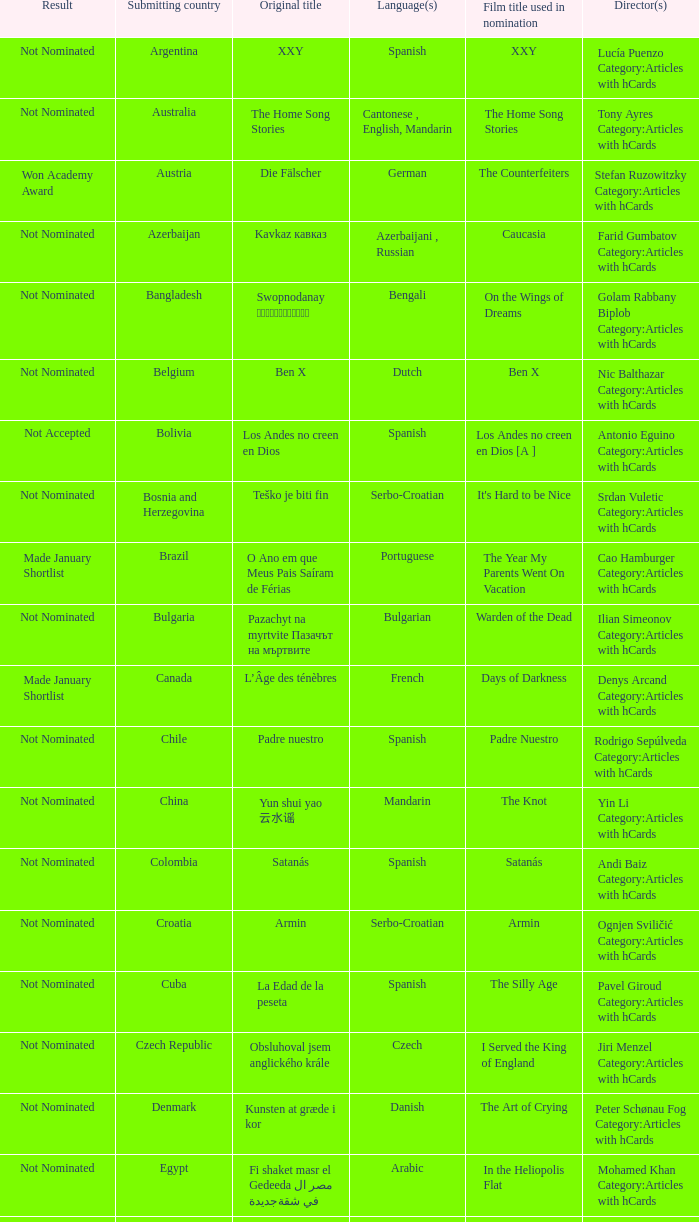What country submitted the movie the orphanage? Spain. Can you parse all the data within this table? {'header': ['Result', 'Submitting country', 'Original title', 'Language(s)', 'Film title used in nomination', 'Director(s)'], 'rows': [['Not Nominated', 'Argentina', 'XXY', 'Spanish', 'XXY', 'Lucía Puenzo Category:Articles with hCards'], ['Not Nominated', 'Australia', 'The Home Song Stories', 'Cantonese , English, Mandarin', 'The Home Song Stories', 'Tony Ayres Category:Articles with hCards'], ['Won Academy Award', 'Austria', 'Die Fälscher', 'German', 'The Counterfeiters', 'Stefan Ruzowitzky Category:Articles with hCards'], ['Not Nominated', 'Azerbaijan', 'Kavkaz кавказ', 'Azerbaijani , Russian', 'Caucasia', 'Farid Gumbatov Category:Articles with hCards'], ['Not Nominated', 'Bangladesh', 'Swopnodanay স্বপ্নডানায়', 'Bengali', 'On the Wings of Dreams', 'Golam Rabbany Biplob Category:Articles with hCards'], ['Not Nominated', 'Belgium', 'Ben X', 'Dutch', 'Ben X', 'Nic Balthazar Category:Articles with hCards'], ['Not Accepted', 'Bolivia', 'Los Andes no creen en Dios', 'Spanish', 'Los Andes no creen en Dios [A ]', 'Antonio Eguino Category:Articles with hCards'], ['Not Nominated', 'Bosnia and Herzegovina', 'Teško je biti fin', 'Serbo-Croatian', "It's Hard to be Nice", 'Srdan Vuletic Category:Articles with hCards'], ['Made January Shortlist', 'Brazil', 'O Ano em que Meus Pais Saíram de Férias', 'Portuguese', 'The Year My Parents Went On Vacation', 'Cao Hamburger Category:Articles with hCards'], ['Not Nominated', 'Bulgaria', 'Pazachyt na myrtvite Пазачът на мъртвите', 'Bulgarian', 'Warden of the Dead', 'Ilian Simeonov Category:Articles with hCards'], ['Made January Shortlist', 'Canada', 'L’Âge des ténèbres', 'French', 'Days of Darkness', 'Denys Arcand Category:Articles with hCards'], ['Not Nominated', 'Chile', 'Padre nuestro', 'Spanish', 'Padre Nuestro', 'Rodrigo Sepúlveda Category:Articles with hCards'], ['Not Nominated', 'China', 'Yun shui yao 云水谣', 'Mandarin', 'The Knot', 'Yin Li Category:Articles with hCards'], ['Not Nominated', 'Colombia', 'Satanás', 'Spanish', 'Satanás', 'Andi Baiz Category:Articles with hCards'], ['Not Nominated', 'Croatia', 'Armin', 'Serbo-Croatian', 'Armin', 'Ognjen Sviličić Category:Articles with hCards'], ['Not Nominated', 'Cuba', 'La Edad de la peseta', 'Spanish', 'The Silly Age', 'Pavel Giroud Category:Articles with hCards'], ['Not Nominated', 'Czech Republic', 'Obsluhoval jsem anglického krále', 'Czech', 'I Served the King of England', 'Jiri Menzel Category:Articles with hCards'], ['Not Nominated', 'Denmark', 'Kunsten at græde i kor', 'Danish', 'The Art of Crying', 'Peter Schønau Fog Category:Articles with hCards'], ['Not Nominated', 'Egypt', 'Fi shaket masr el Gedeeda في شقة مصر الجديدة', 'Arabic', 'In the Heliopolis Flat', 'Mohamed Khan Category:Articles with hCards'], ['Not Nominated', 'Estonia', 'Klass', 'Estonian', 'The Class', 'Ilmar Raag Category:Articles with hCards'], ['Not Nominated', 'Finland', 'Miehen työ', 'Finnish', "A Man's Job", 'Aleksi Salmenperä Category:Articles with hCards'], ['Not Nominated', 'Georgia', 'Rusuli samkudhedi Русский треугольник', 'Russian', 'The Russian Triangle', 'Aleko Tsabadze Category:Articles with hCards'], ['Not Nominated', 'Germany', 'Auf der anderen Seite', 'German, Turkish', 'The Edge of Heaven', 'Fatih Akin Category:Articles with hCards'], ['Not Nominated', 'Greece', 'Eduart', 'Albanian , German, Greek', 'Eduart', 'Angeliki Antoniou Category:Articles with hCards'], ['Not Nominated', 'Hong Kong', 'Fong juk 放逐', 'Cantonese', 'Exiled', 'Johnnie To Category:Articles with hCards'], ['Not Nominated', 'Hungary', 'Taxidermia', 'Hungarian', 'Taxidermia', 'György Pálfi Category:Articles with hCards'], ['Not Nominated', 'Iceland', 'Mýrin', 'Icelandic', 'Jar City', 'Baltasar Kormakur Category:Articles with hCards'], ['Not Nominated', 'India', 'Eklavya: The Royal Guard एकलव्य', 'Hindi', 'Eklavya: The Royal Guard [B ]', 'Vidhu Vinod Chopra Category:Articles with hCards'], ['Not Nominated', 'Indonesia', 'Denias Senandung Di Atas Awan', 'Indonesian', 'Denias, Singing on the Cloud', 'John De Rantau Category:Articles with hCards'], ['Not Nominated', 'Iran', 'Mim Mesle Madar میم مثل مادر', 'Persian', 'M for Mother', 'Rasul Mollagholipour Category:Articles with hCards'], ['Not Nominated', 'Iraq', 'Jani Gal', 'Kurdish', 'Jani Gal', 'Jamil Rostami Category:Articles with hCards'], ['Not Nominated', 'Ireland', 'Kings', 'Irish, English', 'Kings', 'Tommy Collins Category:Articles with hCards'], ['Nominee', 'Israel', 'Beaufort בופור', 'Hebrew', 'Beaufort [C ]', 'Joseph Cedar Category:Articles with hCards'], ['Made January Shortlist', 'Italy', 'La sconosciuta', 'Italian', 'La sconosciuta', 'Giuseppe Tornatore Category:Articles with hCards'], ['Not Nominated', 'Japan', 'Soredemo boku wa yatte nai ( それでもボクはやってない ? )', 'Japanese', "I Just Didn't Do It", 'Masayuki Suo Category:Articles with hCards'], ['Nominee', 'Kazakhstan', 'Mongol Монгол', 'Mongolian', 'Mongol', 'Sergei Bodrov Category:Articles with hCards'], ['Not Nominated', 'Lebanon', 'Sukkar banat سكر بنات', 'Arabic, French', 'Caramel', 'Nadine Labaki Category:Articles with hCards'], ['Not Nominated', 'Luxembourg', 'Perl oder Pica', 'Luxembourgish', 'Little Secrets', 'Pol Cruchten Category:Articles with hCards'], ['Not Nominated', 'Macedonia', 'Senki Сенки', 'Macedonian', 'Shadows', 'Milčo Mančevski Category:Articles with hCards'], ['Not Nominated', 'Mexico', 'Stellet licht', 'Plautdietsch', 'Silent Light', 'Carlos Reygadas Category:Articles with hCards'], ['Not Nominated', 'Netherlands', 'Duska', 'Dutch', 'Duska', 'Jos Stelling Category:Articles with hCards'], ['Not Nominated', 'Norway', 'Tatt av Kvinnen', 'Norwegian', 'Gone with the Woman', 'Petter Naess Category:Articles with hCards'], ['Not Nominated', 'Peru', 'Una sombra al frente', 'Spanish', 'Crossing a Shadow', 'Augusto Tamayo Category:Articles with hCards'], ['Not Nominated', 'Philippines', 'Donsol', 'Bikol , Tagalog', 'Donsol', 'Adolfo Alix, Jr. Category:Articles with hCards'], ['Nominee', 'Poland', 'Katyń', 'Polish', 'Katyń', 'Andrzej Wajda Category:Articles with hCards'], ['Not Nominated', 'Portugal', 'Belle Toujours', 'French', 'Belle Toujours', 'Manoel de Oliveira Category:Articles with hCards'], ['Not Nominated', 'Romania', '4 luni, 3 săptămâni şi 2 zile', 'Romanian', '4 Months, 3 Weeks and 2 Days', 'Cristian Mungiu Category:Articles with hCards'], ['Nominee', 'Russia', '12', 'Russian, Chechen', '12', 'Nikita Mikhalkov Category:Articles with hCards'], ['Made January Shortlist', 'Serbia', 'Klopka Клопка', 'Serbo-Croatian', 'The Trap', 'Srdan Golubović Category:Articles with hCards'], ['Not Nominated', 'Singapore', '881', 'Mandarin , Hokkien', '881', 'Royston Tan Category:Articles with hCards'], ['Not Nominated', 'Slovakia', 'Návrat bocianov', 'German , Slovak', 'Return of the Storks', 'Martin Repka Category:Articles with hCards'], ['Not Nominated', 'Slovenia', 'Kratki stiki', 'Slovene', 'Short Circuits', 'Janez Lapajne Category:Articles with hCards'], ['Not Nominated', 'South Korea', 'Milyang 밀양', 'Korean', 'Secret Sunshine', 'Lee Chang-dong Category:Articles with hCards'], ['Not Nominated', 'Spain', 'El orfanato', 'Spanish', 'The Orphanage', 'Juan Antonio Bayona Category:Articles with hCards'], ['Not Nominated', 'Sweden', 'Du levande', 'Swedish', 'You, the Living', 'Roy Andersson Category:Articles with hCards'], ['Not Nominated', 'Switzerland', 'Die Herbstzeitlosen', 'Swiss German', 'Late Bloomers', 'Bettina Oberli Category:Articles with hCards'], ['Not Nominated', 'Taiwan', 'Liànxí Qǔ 練習曲', 'Mandarin , Taiwanese', 'Island Etude [D ]', 'Chen Huai-En Category:Articles with hCards'], ['Not Nominated', 'Turkey', 'Takva', 'Turkish', "A Man's Fear of God", 'Özer Kızıltan Category:Articles with hCards'], ['Not Nominated', 'Venezuela', 'Postales de Leningrado', 'Spanish', 'Postcards from Leningrad', 'Mariana Rondon Category:Articles with hCards']]} 